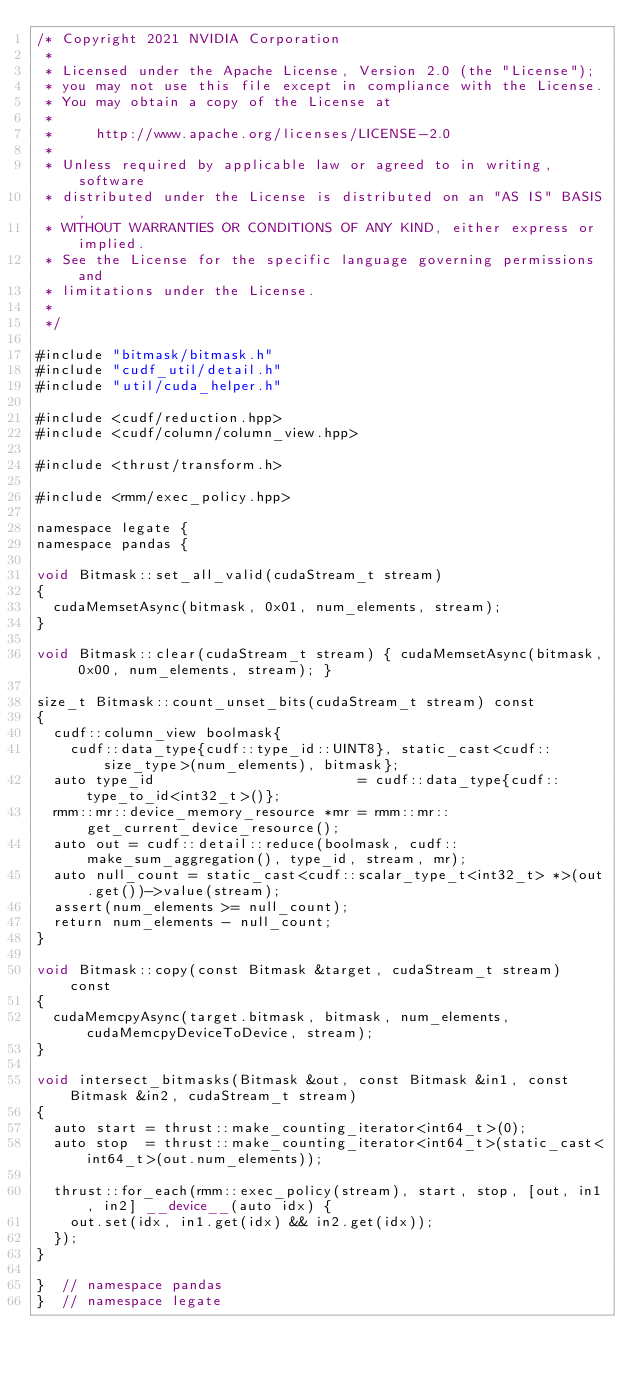<code> <loc_0><loc_0><loc_500><loc_500><_Cuda_>/* Copyright 2021 NVIDIA Corporation
 *
 * Licensed under the Apache License, Version 2.0 (the "License");
 * you may not use this file except in compliance with the License.
 * You may obtain a copy of the License at
 *
 *     http://www.apache.org/licenses/LICENSE-2.0
 *
 * Unless required by applicable law or agreed to in writing, software
 * distributed under the License is distributed on an "AS IS" BASIS,
 * WITHOUT WARRANTIES OR CONDITIONS OF ANY KIND, either express or implied.
 * See the License for the specific language governing permissions and
 * limitations under the License.
 *
 */

#include "bitmask/bitmask.h"
#include "cudf_util/detail.h"
#include "util/cuda_helper.h"

#include <cudf/reduction.hpp>
#include <cudf/column/column_view.hpp>

#include <thrust/transform.h>

#include <rmm/exec_policy.hpp>

namespace legate {
namespace pandas {

void Bitmask::set_all_valid(cudaStream_t stream)
{
  cudaMemsetAsync(bitmask, 0x01, num_elements, stream);
}

void Bitmask::clear(cudaStream_t stream) { cudaMemsetAsync(bitmask, 0x00, num_elements, stream); }

size_t Bitmask::count_unset_bits(cudaStream_t stream) const
{
  cudf::column_view boolmask{
    cudf::data_type{cudf::type_id::UINT8}, static_cast<cudf::size_type>(num_elements), bitmask};
  auto type_id                        = cudf::data_type{cudf::type_to_id<int32_t>()};
  rmm::mr::device_memory_resource *mr = rmm::mr::get_current_device_resource();
  auto out = cudf::detail::reduce(boolmask, cudf::make_sum_aggregation(), type_id, stream, mr);
  auto null_count = static_cast<cudf::scalar_type_t<int32_t> *>(out.get())->value(stream);
  assert(num_elements >= null_count);
  return num_elements - null_count;
}

void Bitmask::copy(const Bitmask &target, cudaStream_t stream) const
{
  cudaMemcpyAsync(target.bitmask, bitmask, num_elements, cudaMemcpyDeviceToDevice, stream);
}

void intersect_bitmasks(Bitmask &out, const Bitmask &in1, const Bitmask &in2, cudaStream_t stream)
{
  auto start = thrust::make_counting_iterator<int64_t>(0);
  auto stop  = thrust::make_counting_iterator<int64_t>(static_cast<int64_t>(out.num_elements));

  thrust::for_each(rmm::exec_policy(stream), start, stop, [out, in1, in2] __device__(auto idx) {
    out.set(idx, in1.get(idx) && in2.get(idx));
  });
}

}  // namespace pandas
}  // namespace legate
</code> 